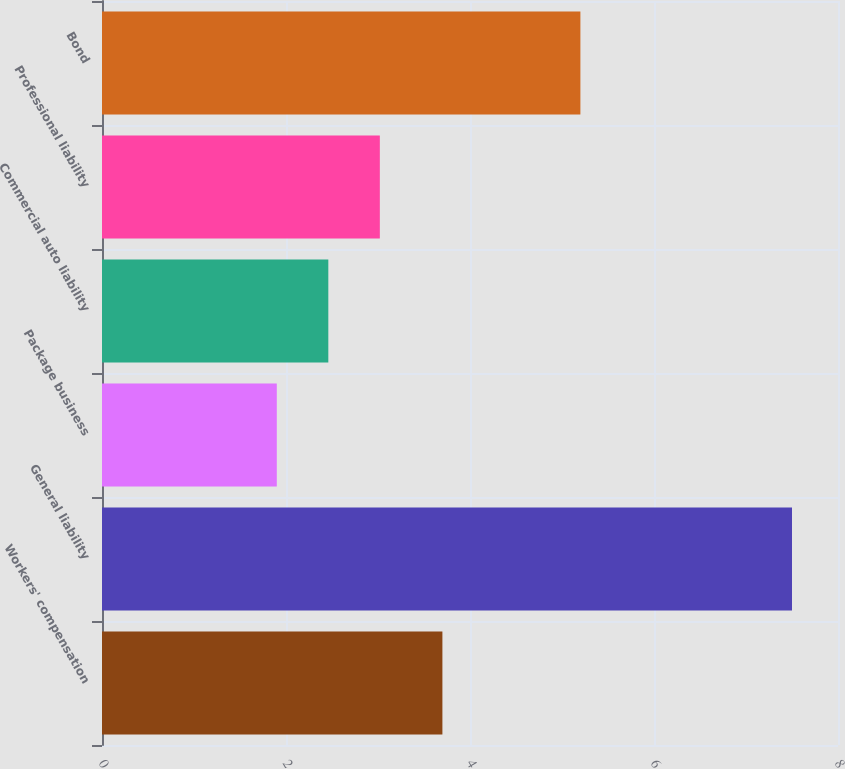Convert chart to OTSL. <chart><loc_0><loc_0><loc_500><loc_500><bar_chart><fcel>Workers' compensation<fcel>General liability<fcel>Package business<fcel>Commercial auto liability<fcel>Professional liability<fcel>Bond<nl><fcel>3.7<fcel>7.5<fcel>1.9<fcel>2.46<fcel>3.02<fcel>5.2<nl></chart> 